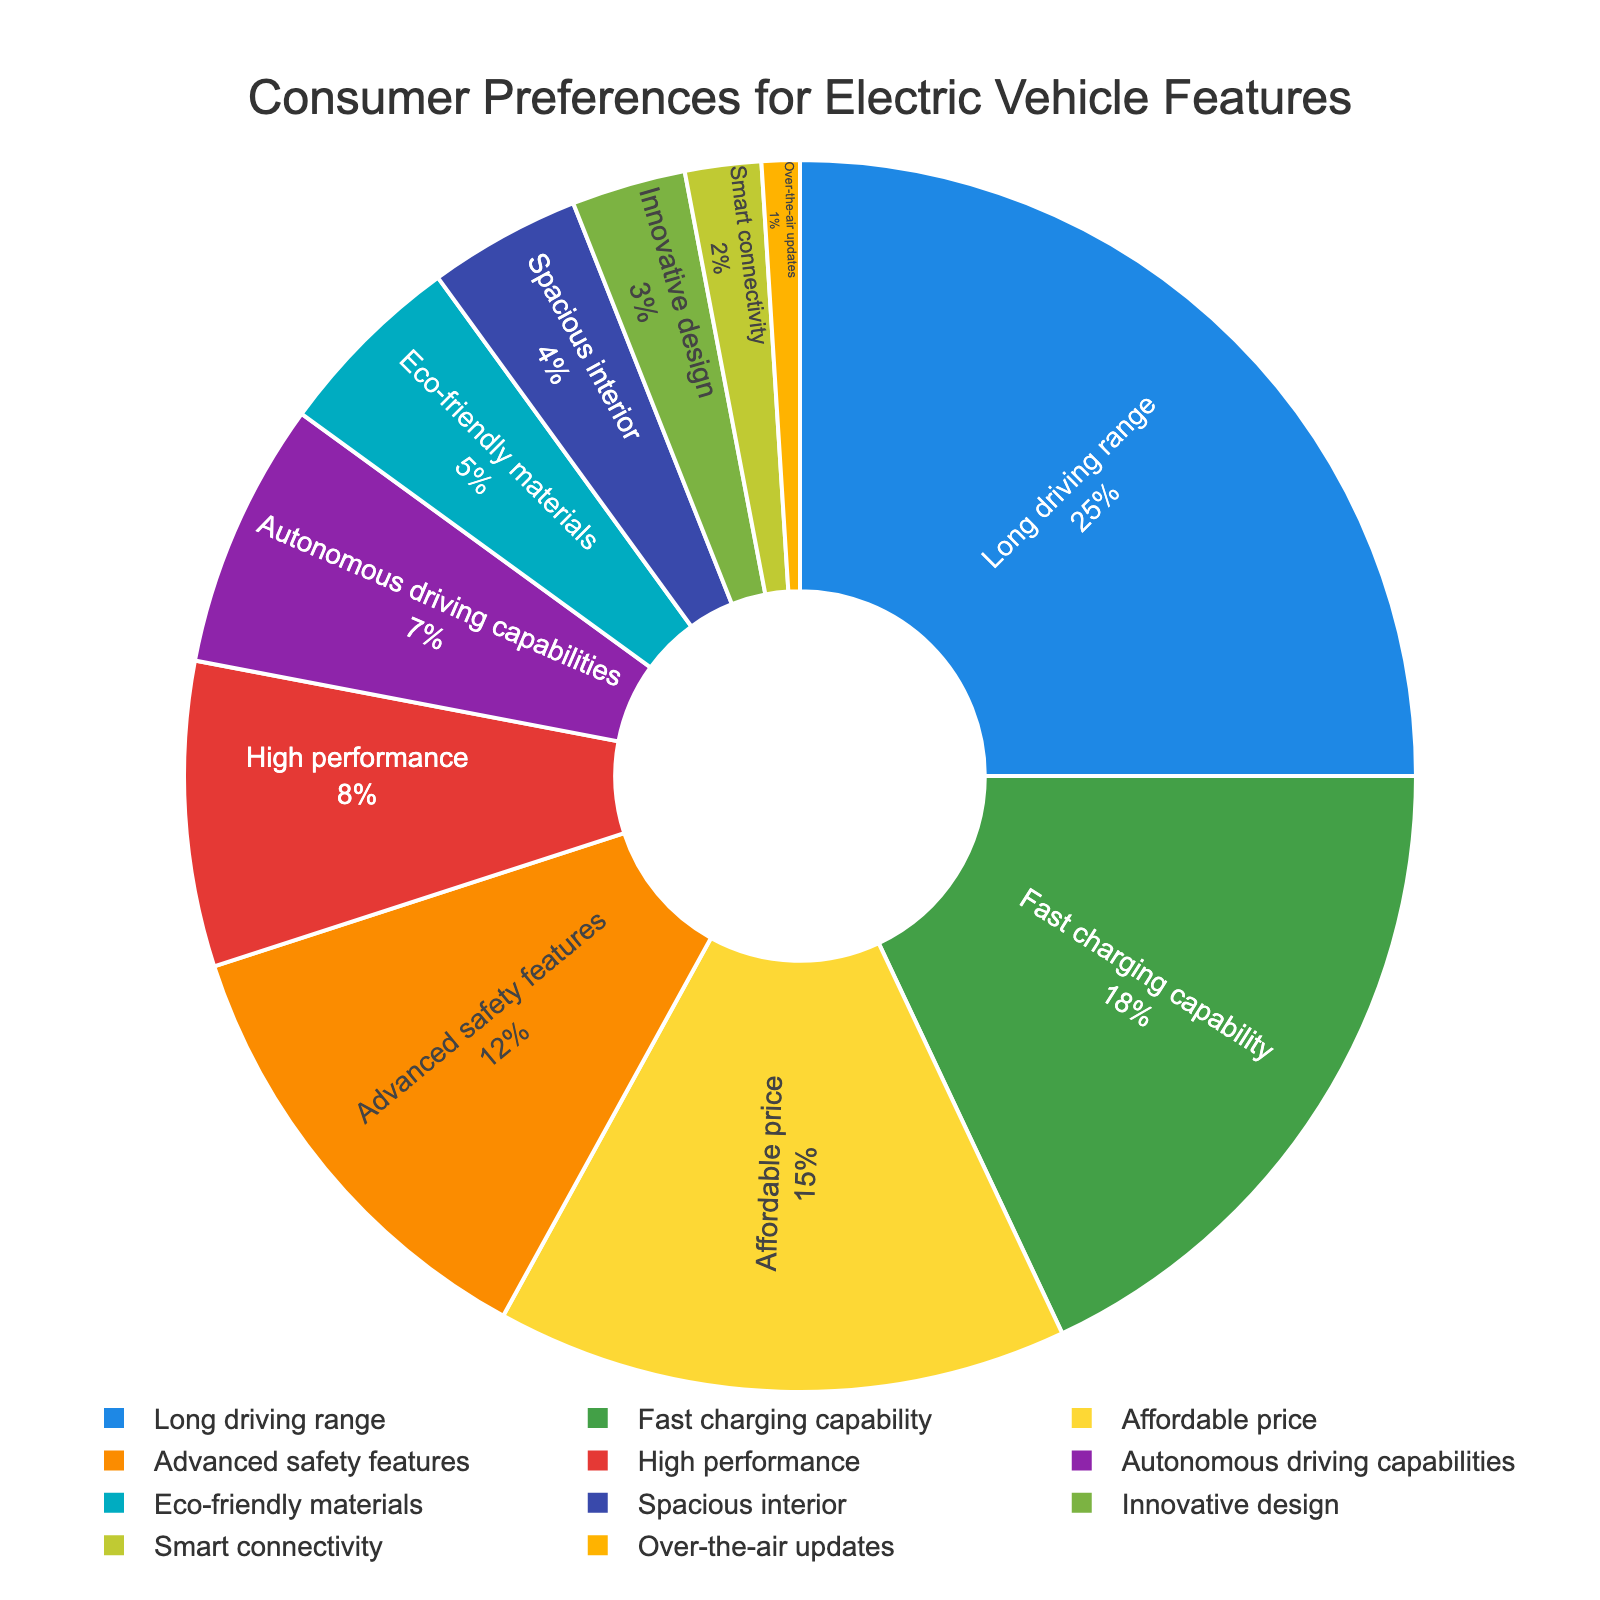What's the most preferred feature for electric vehicles? To find the most preferred feature, look for the largest segment in the pie chart. The segment labeled "Long driving range" takes up the largest portion of the pie, indicating it has the highest percentage.
Answer: Long driving range Which two features have the closest percentage of consumer preferences? Identify features with similar-sized segments. "High performance" and "Autonomous driving capabilities" have percentages of 8% and 7% respectively, making them the closest in size among the segments.
Answer: High performance and Autonomous driving capabilities What's the total percentage of consumers who prioritize Advanced safety features, High performance, and Autonomous driving capabilities combined? Add the percentages: Advanced safety features (12%), High performance (8%), and Autonomous driving capabilities (7%). The sum is 12% + 8% + 7% = 27%.
Answer: 27% What is the least preferred feature according to the pie chart? Look for the smallest segment in the pie chart. The segment labeled "Over-the-air updates" is the smallest, indicating it has the lowest percentage.
Answer: Over-the-air updates How much more preferred is Long driving range compared to Affordable price? Compare the percentages for these two features: Long driving range (25%) and Affordable price (15%). The difference is 25% - 15% = 10%.
Answer: 10% If you combine the percentages for Fast charging capability and Affordable price, how does it compare to Long driving range? Sum the percentages of Fast charging capability (18%) and Affordable price (15%): 18% + 15% = 33%. Compare it to the percentage for Long driving range, which is 25%. 33% is greater than 25%.
Answer: 33% is greater What is the combined percentage of consumers who prefer Eco-friendly materials and Smart connectivity? Add the percentages for Eco-friendly materials (5%) and Smart connectivity (2%): 5% + 2% = 7%.
Answer: 7% Which feature has a higher consumer preference: Innovative design or Spacious interior? Compare the percentages: Innovative design has 3% while Spacious interior has 4%. Spacious interior has the higher preference.
Answer: Spacious interior How many features have a consumer preference percentage of 10% or higher? Count the segments with percentages of 10% or higher. They are Long driving range (25%), Fast charging capability (18%), Affordable price (15%), and Advanced safety features (12%). There are four such features.
Answer: 4 